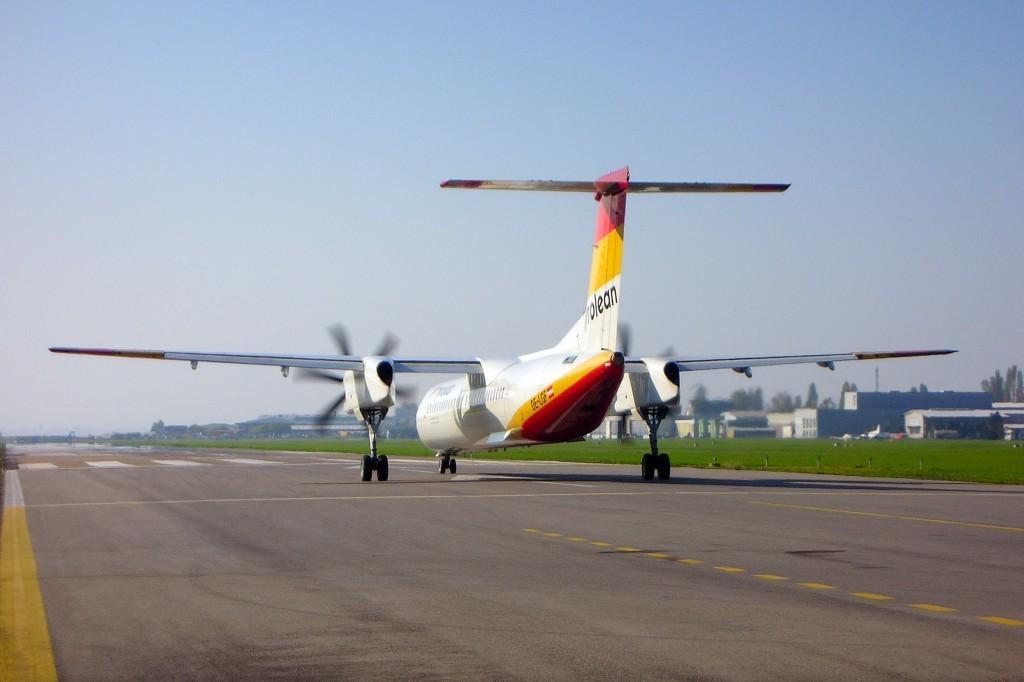Could you give a brief overview of what you see in this image? In this image, in the middle, we can see an airplane moving on the road. On the right side, we can see some buildings, trees. At the top, we can see a sky, at the bottom there is a road and a grass. 